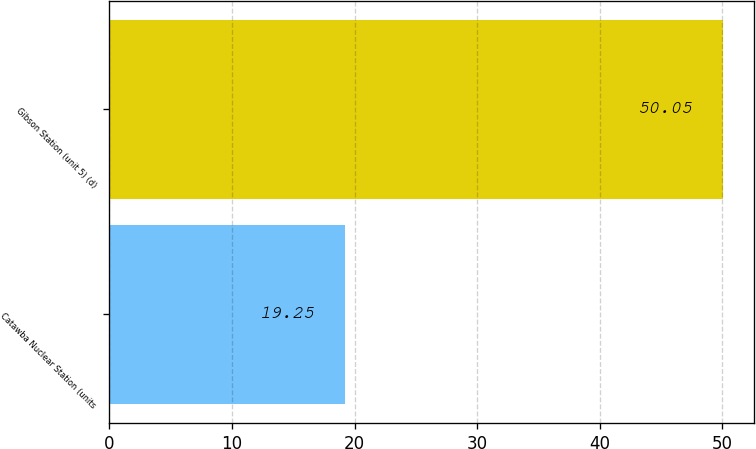Convert chart to OTSL. <chart><loc_0><loc_0><loc_500><loc_500><bar_chart><fcel>Catawba Nuclear Station (units<fcel>Gibson Station (unit 5) (d)<nl><fcel>19.25<fcel>50.05<nl></chart> 